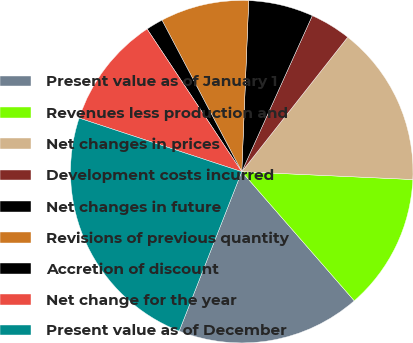Convert chart to OTSL. <chart><loc_0><loc_0><loc_500><loc_500><pie_chart><fcel>Present value as of January 1<fcel>Revenues less production and<fcel>Net changes in prices<fcel>Development costs incurred<fcel>Net changes in future<fcel>Revisions of previous quantity<fcel>Accretion of discount<fcel>Net change for the year<fcel>Present value as of December<nl><fcel>17.36%<fcel>12.86%<fcel>15.11%<fcel>3.86%<fcel>6.11%<fcel>8.36%<fcel>1.61%<fcel>10.61%<fcel>24.11%<nl></chart> 